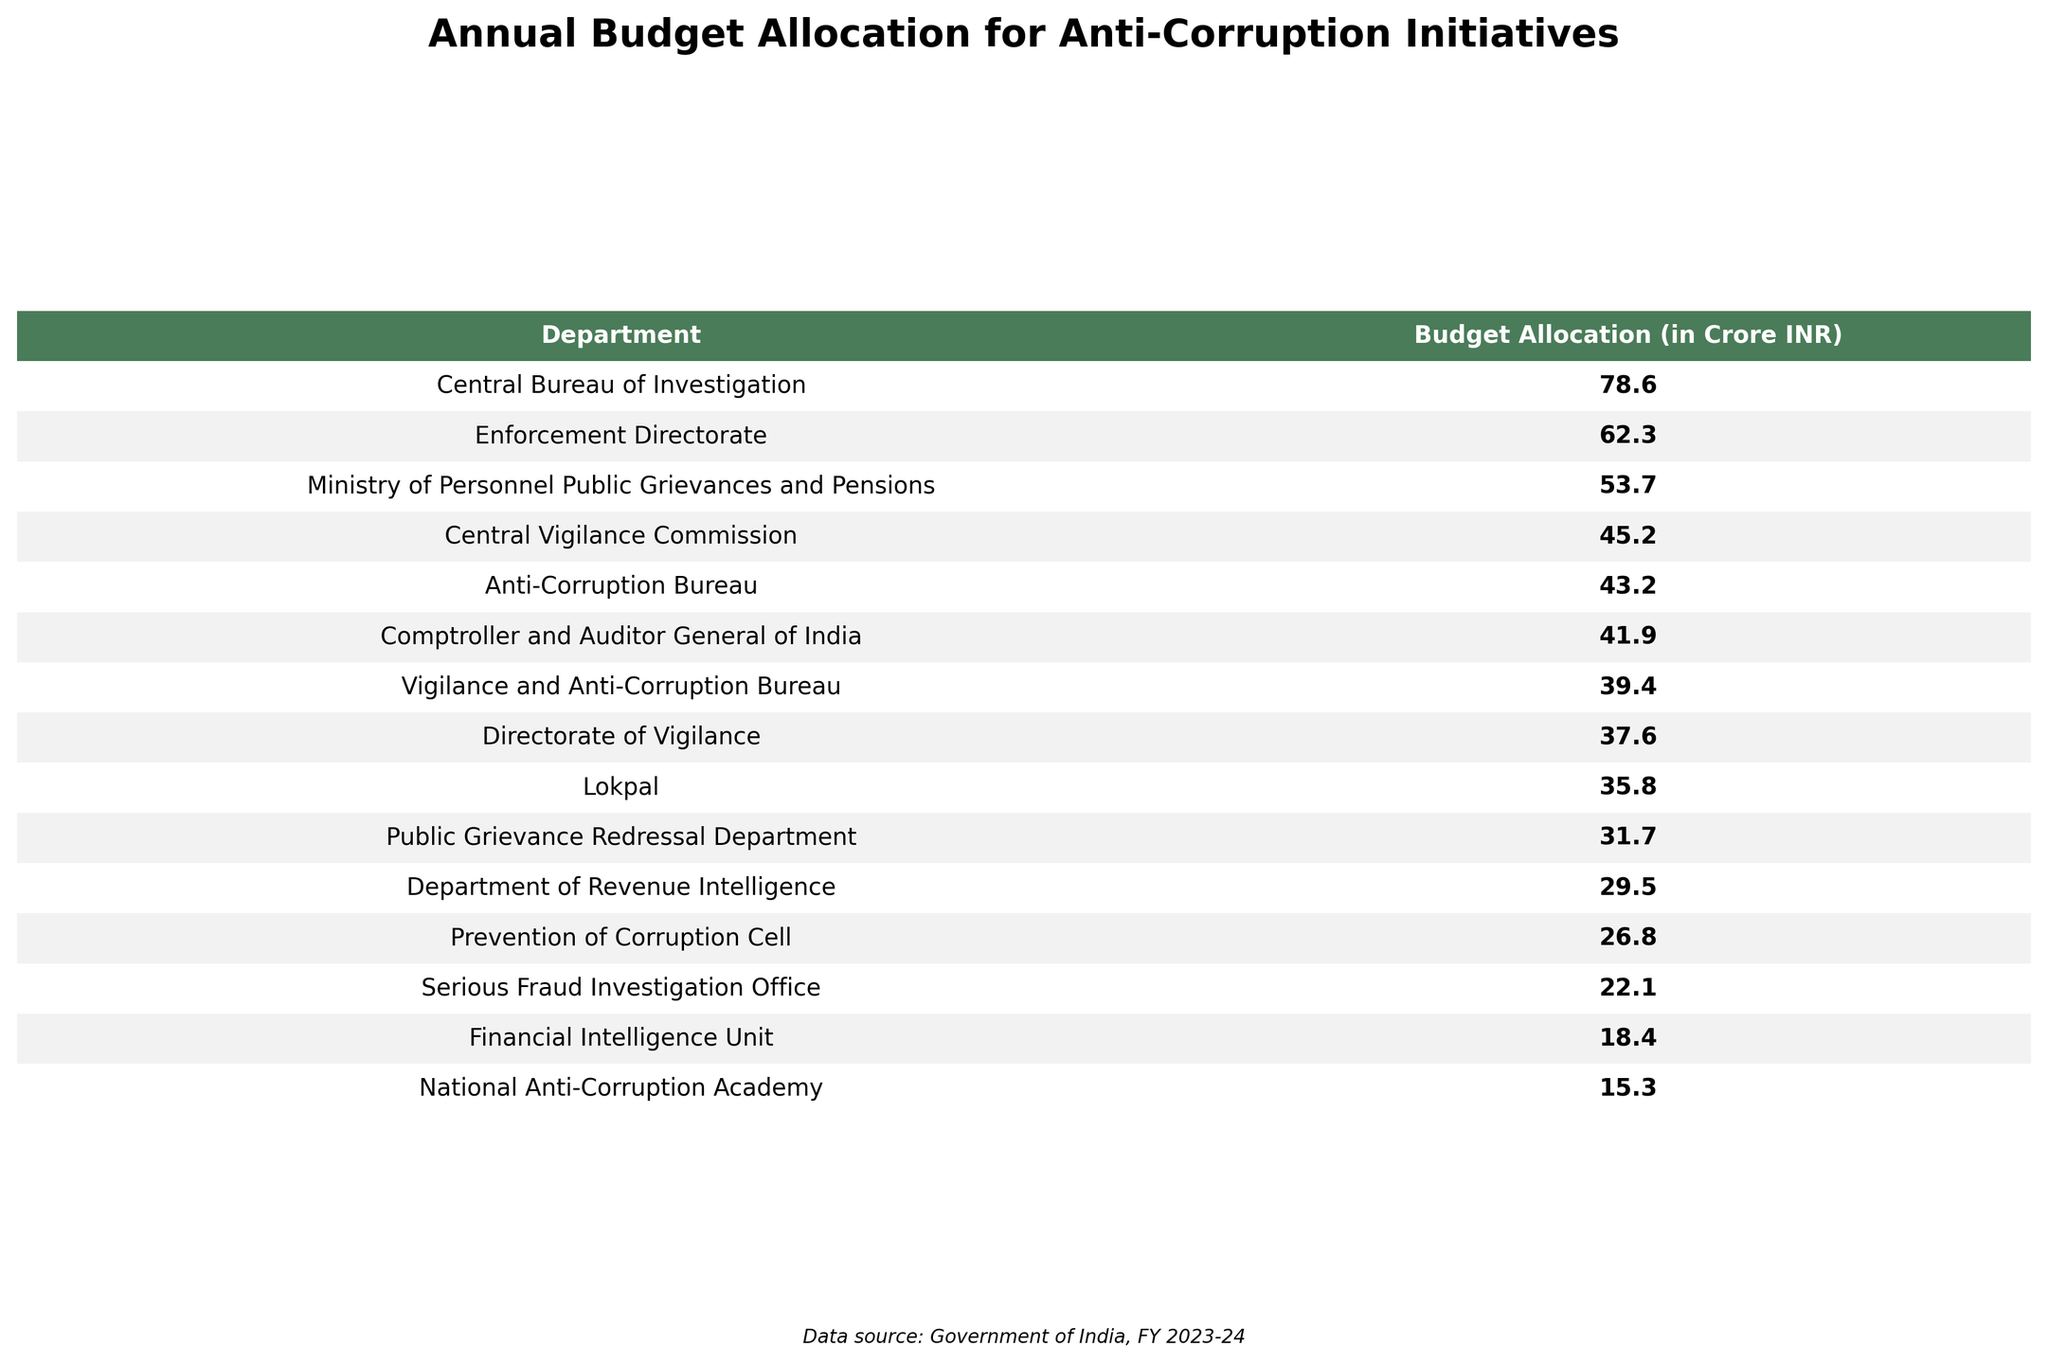What is the highest budget allocation for anti-corruption initiatives? The table clearly shows that the Central Bureau of Investigation has the highest budget allocation at 78.6 Crore INR.
Answer: 78.6 Crore INR Which department has the least budget allocation? According to the table, the National Anti-Corruption Academy has the least budget allocation with 15.3 Crore INR.
Answer: 15.3 Crore INR What is the total budget allocation for all the departments listed? To find the total, we add the budget allocations of all departments together: 45.2 + 78.6 + 62.3 + 35.8 + 53.7 + 41.9 + 29.5 + 18.4 + 22.1 + 37.6 + 15.3 + 26.8 + 43.2 + 31.7 + 39.4 =  496.6 Crore INR.
Answer: 496.6 Crore INR Is the budget allocation for the Enforcement Directorate greater than the average budget allocation for all departments? First, we calculate the average by dividing the total budget by the number of departments: 496.6 / 15 = 33.1 Crore INR (approximately). The Enforcement Directorate's budget is 62.3 Crore INR, which is greater than 33.1 Crore INR.
Answer: Yes What is the difference in budget allocation between the Central Vigilance Commission and the Lokpal? We subtract the budget allocation of the Lokpal from that of the Central Vigilance Commission: 45.2 - 35.8 = 9.4 Crore INR.
Answer: 9.4 Crore INR Are there any departments with a budget allocation greater than 50 Crore INR? Looking through the table, the Central Bureau of Investigation, Enforcement Directorate, Ministry of Personnel Public Grievances and Pensions, and Anti-Corruption Bureau all have allocations greater than 50 Crore INR. Thus, the answer is yes.
Answer: Yes What is the combined budget allocation for the Directorate of Vigilance and the Prevention of Corruption Cell? We add the budget allocations of these two departments: 37.6 (Directorate of Vigilance) + 26.8 (Prevention of Corruption Cell) = 64.4 Crore INR.
Answer: 64.4 Crore INR Which two departments have budget allocations closest to each other? By inspecting the table, the budgets for the Public Grievance Redressal Department (31.7) and the Prevention of Corruption Cell (26.8) are the closest based on their numerical difference of 4.9 Crore INR.
Answer: Public Grievance Redressal Department and Prevention of Corruption Cell What percentage of the total budget allocation does the Central Bureau of Investigation’s allocation represent? First, determine the total budget as 496.6 Crore INR. Next, we compute the percentage: (78.6 / 496.6) * 100 ≈ 15.8%.
Answer: 15.8% 